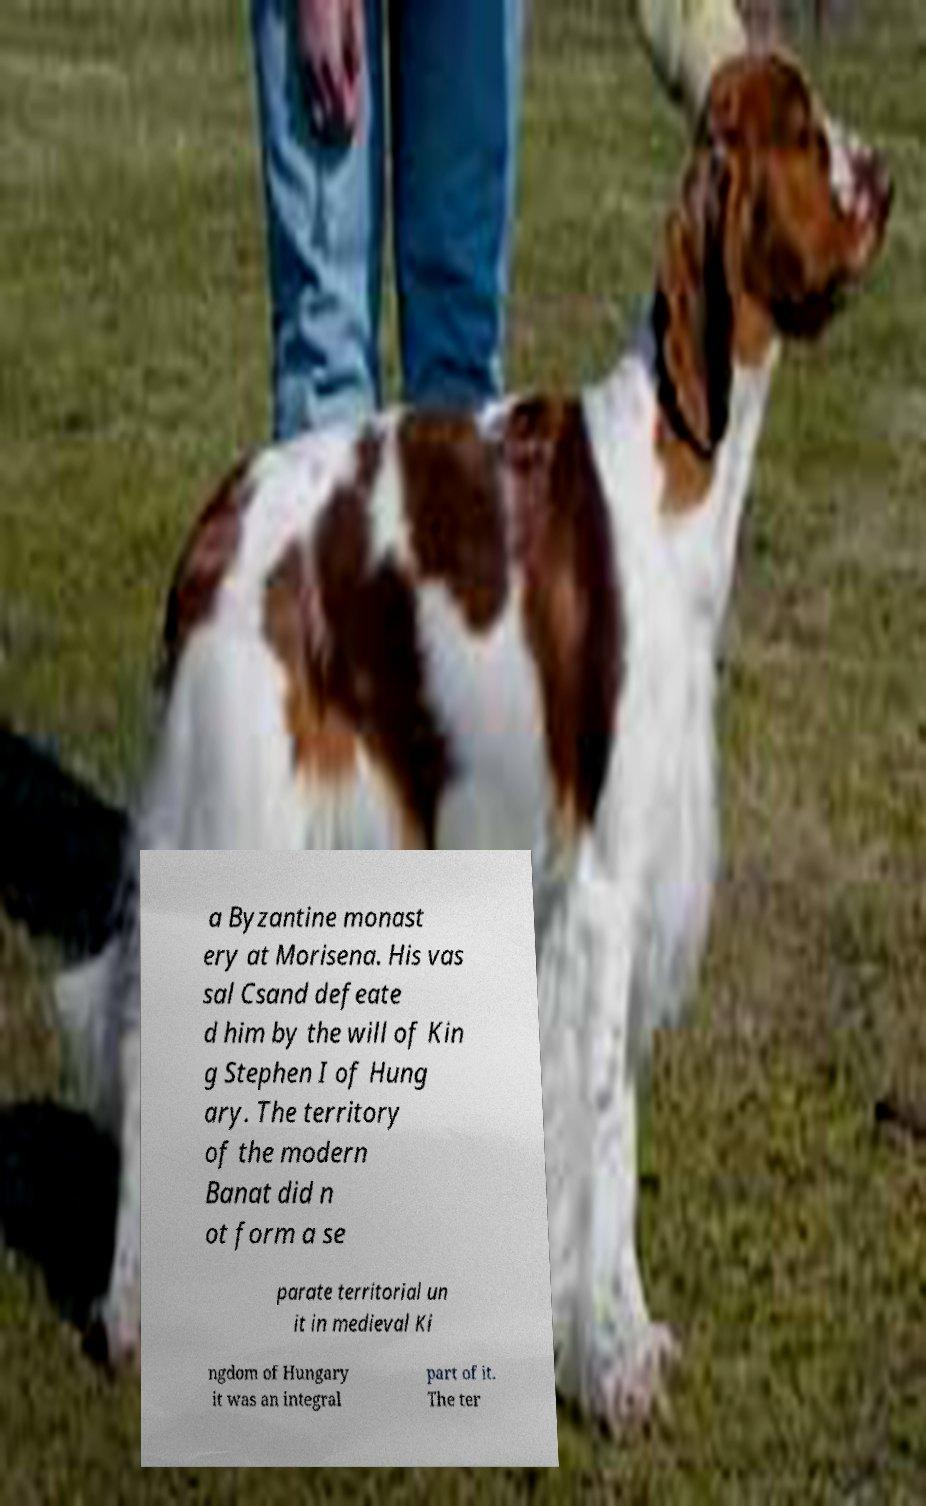There's text embedded in this image that I need extracted. Can you transcribe it verbatim? a Byzantine monast ery at Morisena. His vas sal Csand defeate d him by the will of Kin g Stephen I of Hung ary. The territory of the modern Banat did n ot form a se parate territorial un it in medieval Ki ngdom of Hungary it was an integral part of it. The ter 